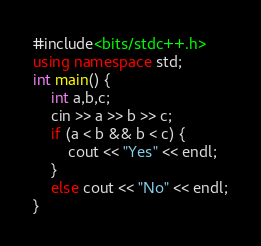Convert code to text. <code><loc_0><loc_0><loc_500><loc_500><_C++_>#include<bits/stdc++.h>
using namespace std;
int main() {
    int a,b,c;
    cin >> a >> b >> c;
    if (a < b && b < c) {
        cout << "Yes" << endl;
    }
    else cout << "No" << endl;
}

</code> 